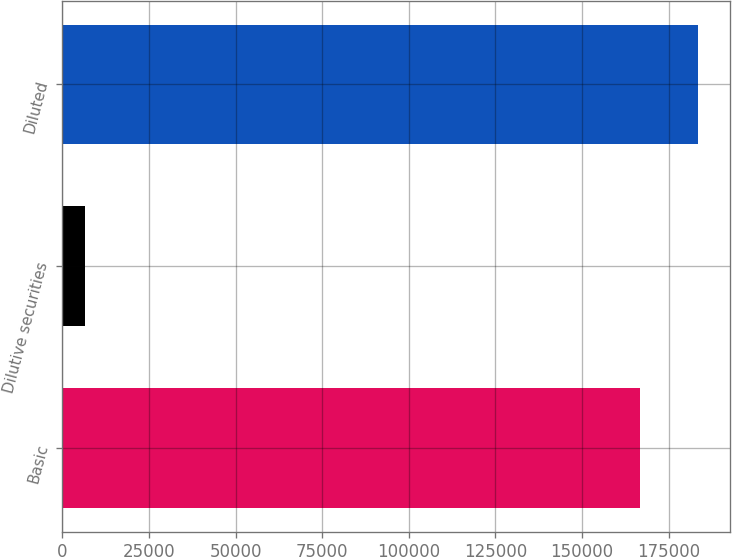Convert chart to OTSL. <chart><loc_0><loc_0><loc_500><loc_500><bar_chart><fcel>Basic<fcel>Dilutive securities<fcel>Diluted<nl><fcel>166679<fcel>6708<fcel>183347<nl></chart> 